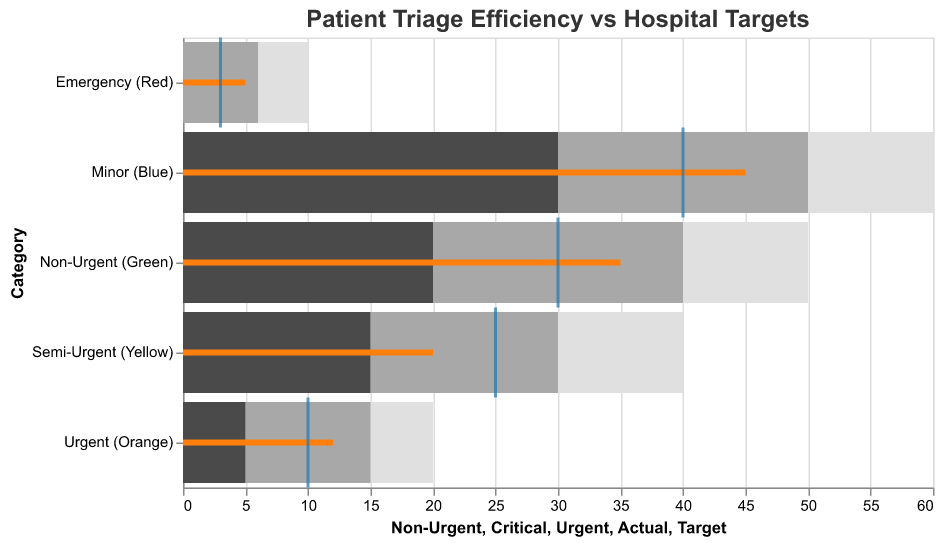What is the title of the figure? Look at the top of the figure. The title is usually displayed there.
Answer: Patient Triage Efficiency vs Hospital Targets What colors indicate different levels of urgency in the plot? Identify the colors used in the chart legend or directly from the labels on the y-axis.
Answer: Emergency (Red) is red, Urgent (Orange) is orange, Semi-Urgent (Yellow) is yellow, Non-Urgent (Green) is green, Minor (Blue) is blue How many categories are represented in the figure? Count the number of unique categories listed on the y-axis or in the legend.
Answer: 5 What is the actual triage time for the Emergency (Red) category? Locate the bar labeled Emergency (Red) and identify the length of the orange bar representing the actual time.
Answer: 5 Which category has the highest target triage time? Compare the positions of the ticks (blue marks) on the x-axis for all categories and find the one with the maximum value.
Answer: Minor (Blue) What is the difference between the actual and target triage times for the Urgent (Orange) category? Subtract the target triage time (blue tick position) from the actual triage time (orange bar value) for Urgent (Orange).
Answer: 2 Which category has the least actual triage time? Look for the shortest orange bar in the figure.
Answer: Emergency (Red) How far did the Semi-Urgent (Yellow) category miss its target? Subtract the target triage time (blue tick position) from the actual triage time (orange bar value) for Semi-Urgent (Yellow).
Answer: -5 (exceeded target by 5) What are the urgent and non-urgent triage times for the Non-Urgent (Green) category? Refer to the encoded segment colors to find the urgent (light gray) and non-urgent (dark gray) values for Non-Urgent (Green).
Answer: 40 (Urgent), 50 (Non-Urgent) Which categories have actual triage times equal to or exceeding their target times? Identify categories where the orange bar meets or exceeds the blue tick. Compare the exact lengths of the orange bars and blue ticks.
Answer: Emergency (Red), Urgent (Orange), Non-Urgent (Green), Minor (Blue) 